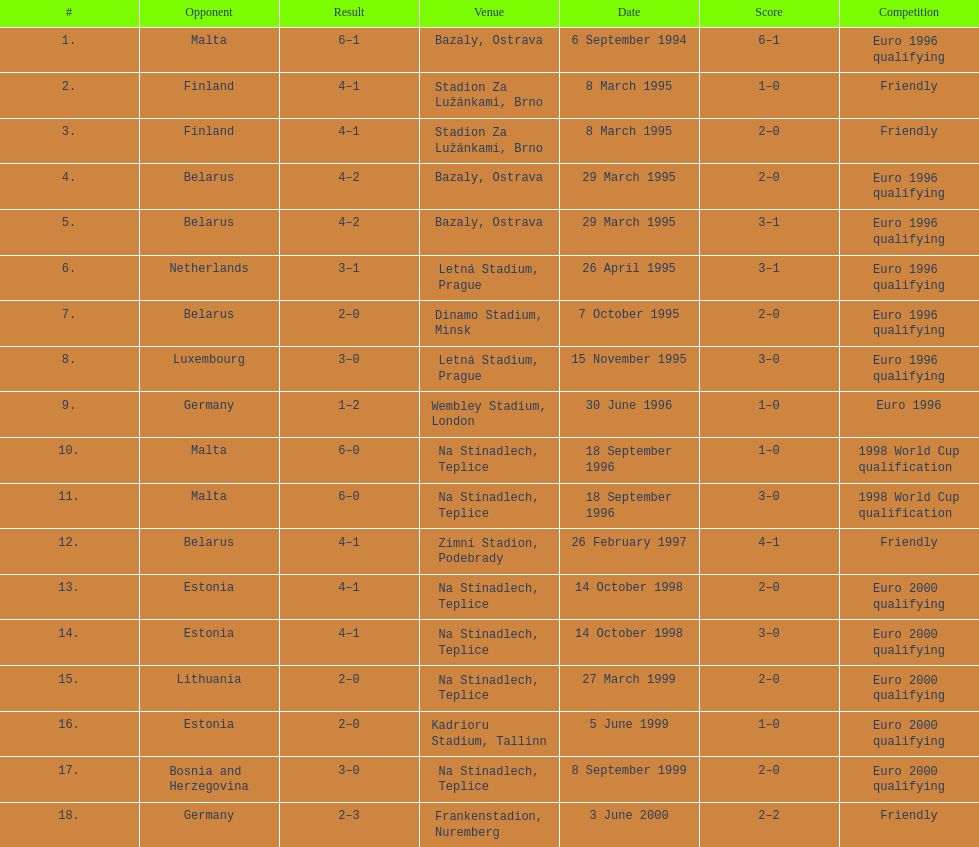List the opponents which are under the friendly competition. Finland, Belarus, Germany. 